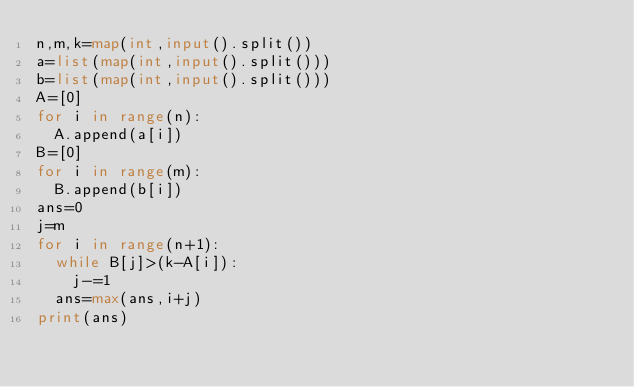Convert code to text. <code><loc_0><loc_0><loc_500><loc_500><_Python_>n,m,k=map(int,input().split())
a=list(map(int,input().split()))
b=list(map(int,input().split()))
A=[0]
for i in range(n):
  A.append(a[i])
B=[0]
for i in range(m):
  B.append(b[i])
ans=0
j=m
for i in range(n+1):
  while B[j]>(k-A[i]):
    j-=1
  ans=max(ans,i+j)
print(ans)</code> 